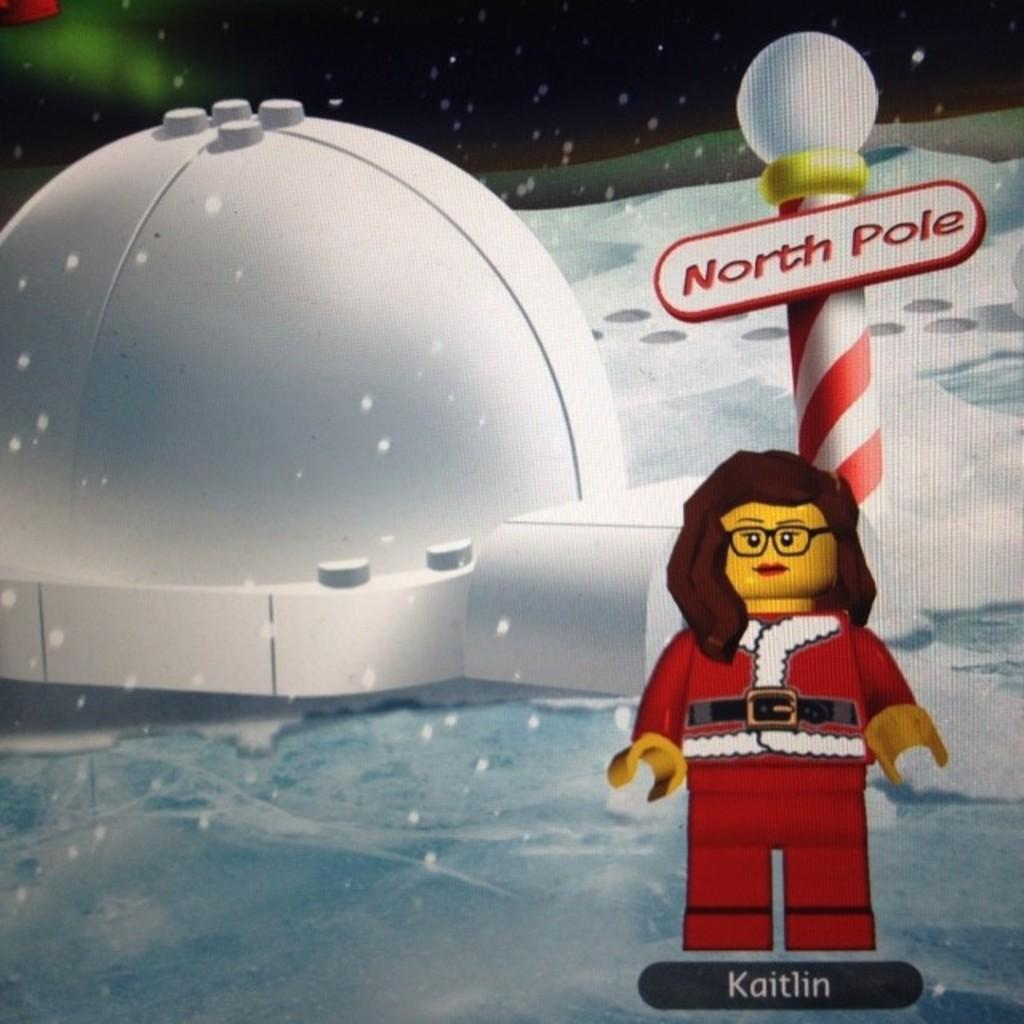What type of structure is depicted in the animation? The animation contains an image of an igloo. What other objects can be seen in the animation? The animation contains an image of a pole and a toy. What is the weather like in the animation? There is snow visible in the animation. Is there any text present in the animation? Yes, there is text present in the animation. What type of linen is used to cover the igloo in the animation? There is no linen present in the animation; it contains an image of an igloo made of snow. What color is the skin of the toy in the animation? The animation contains an image of a toy, but it does not show the toy's skin or any other details about its appearance. 